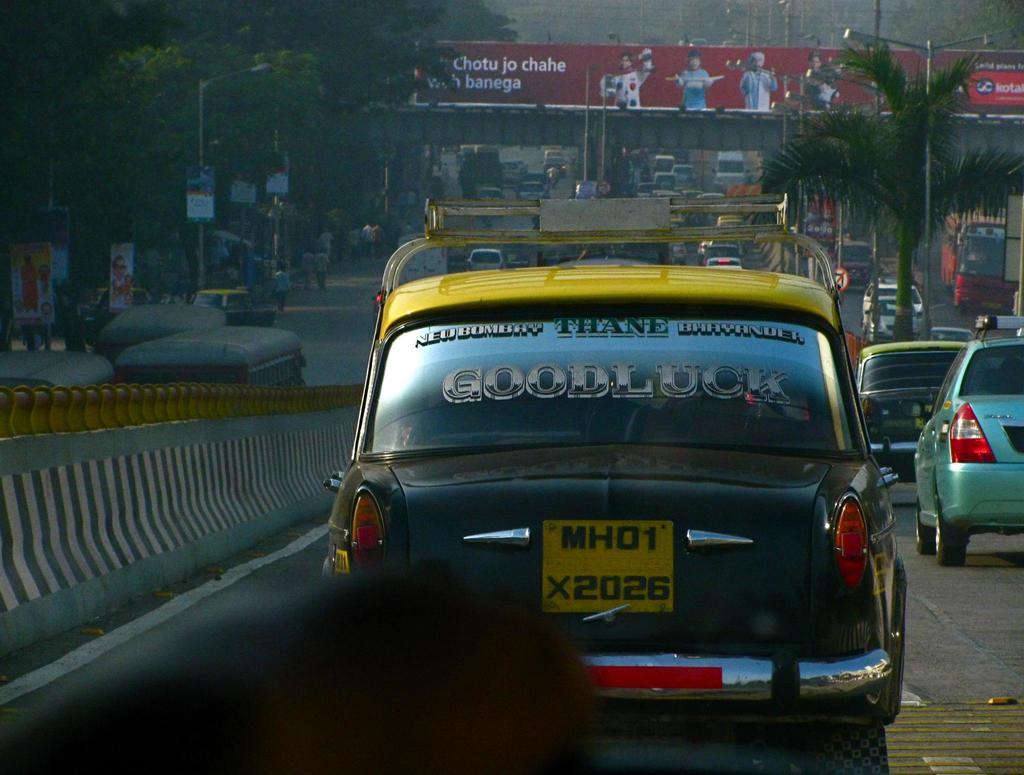What word is in large font on the back window of the black and yellow car?
Your answer should be very brief. Goodluck. What is the licence plate of the car?
Offer a terse response. Mh01 x2026. 